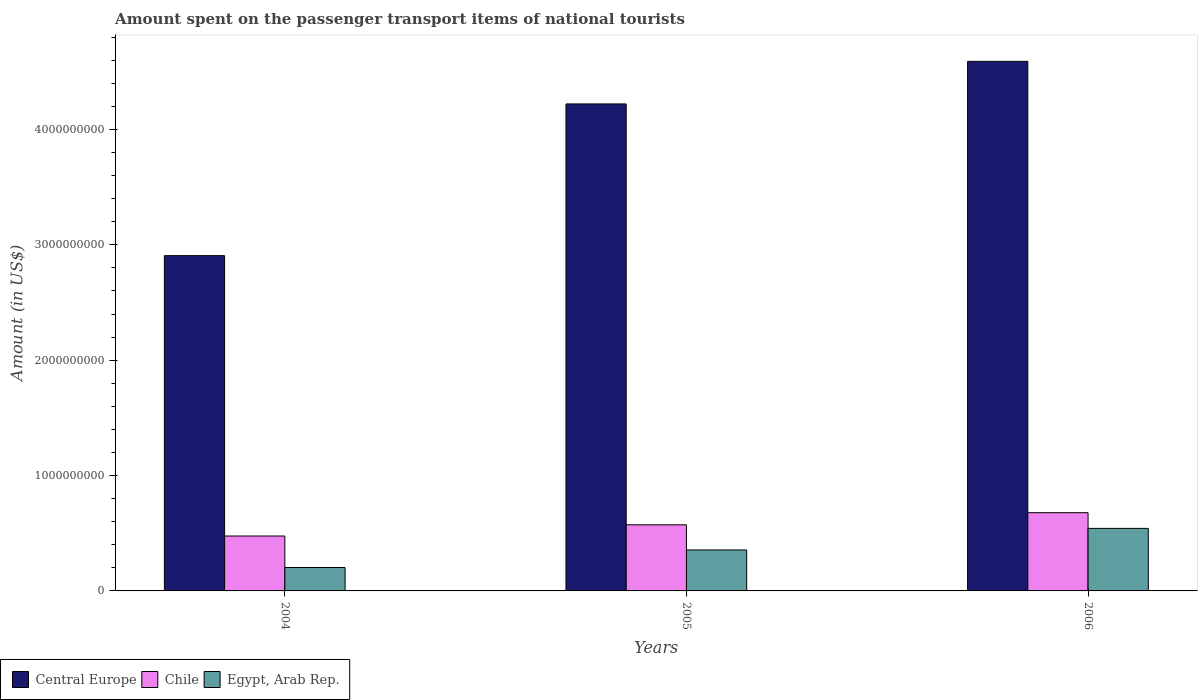How many different coloured bars are there?
Provide a succinct answer. 3. Are the number of bars per tick equal to the number of legend labels?
Keep it short and to the point. Yes. Are the number of bars on each tick of the X-axis equal?
Your response must be concise. Yes. How many bars are there on the 3rd tick from the left?
Provide a succinct answer. 3. How many bars are there on the 1st tick from the right?
Your answer should be compact. 3. What is the label of the 2nd group of bars from the left?
Offer a terse response. 2005. What is the amount spent on the passenger transport items of national tourists in Chile in 2006?
Give a very brief answer. 6.78e+08. Across all years, what is the maximum amount spent on the passenger transport items of national tourists in Egypt, Arab Rep.?
Your answer should be compact. 5.42e+08. Across all years, what is the minimum amount spent on the passenger transport items of national tourists in Chile?
Make the answer very short. 4.76e+08. In which year was the amount spent on the passenger transport items of national tourists in Chile minimum?
Make the answer very short. 2004. What is the total amount spent on the passenger transport items of national tourists in Egypt, Arab Rep. in the graph?
Give a very brief answer. 1.10e+09. What is the difference between the amount spent on the passenger transport items of national tourists in Central Europe in 2004 and that in 2006?
Provide a succinct answer. -1.68e+09. What is the difference between the amount spent on the passenger transport items of national tourists in Egypt, Arab Rep. in 2005 and the amount spent on the passenger transport items of national tourists in Central Europe in 2006?
Give a very brief answer. -4.24e+09. What is the average amount spent on the passenger transport items of national tourists in Chile per year?
Provide a succinct answer. 5.76e+08. In the year 2005, what is the difference between the amount spent on the passenger transport items of national tourists in Central Europe and amount spent on the passenger transport items of national tourists in Egypt, Arab Rep.?
Make the answer very short. 3.87e+09. What is the ratio of the amount spent on the passenger transport items of national tourists in Egypt, Arab Rep. in 2005 to that in 2006?
Ensure brevity in your answer.  0.65. What is the difference between the highest and the second highest amount spent on the passenger transport items of national tourists in Chile?
Offer a terse response. 1.05e+08. What is the difference between the highest and the lowest amount spent on the passenger transport items of national tourists in Egypt, Arab Rep.?
Make the answer very short. 3.39e+08. In how many years, is the amount spent on the passenger transport items of national tourists in Egypt, Arab Rep. greater than the average amount spent on the passenger transport items of national tourists in Egypt, Arab Rep. taken over all years?
Provide a succinct answer. 1. What does the 1st bar from the left in 2005 represents?
Your response must be concise. Central Europe. What does the 1st bar from the right in 2006 represents?
Give a very brief answer. Egypt, Arab Rep. Is it the case that in every year, the sum of the amount spent on the passenger transport items of national tourists in Chile and amount spent on the passenger transport items of national tourists in Egypt, Arab Rep. is greater than the amount spent on the passenger transport items of national tourists in Central Europe?
Give a very brief answer. No. Are all the bars in the graph horizontal?
Make the answer very short. No. How many years are there in the graph?
Offer a terse response. 3. Are the values on the major ticks of Y-axis written in scientific E-notation?
Ensure brevity in your answer.  No. Does the graph contain grids?
Make the answer very short. No. Where does the legend appear in the graph?
Provide a succinct answer. Bottom left. How many legend labels are there?
Make the answer very short. 3. What is the title of the graph?
Your answer should be compact. Amount spent on the passenger transport items of national tourists. Does "Middle East & North Africa (developing only)" appear as one of the legend labels in the graph?
Your response must be concise. No. What is the label or title of the Y-axis?
Make the answer very short. Amount (in US$). What is the Amount (in US$) of Central Europe in 2004?
Make the answer very short. 2.91e+09. What is the Amount (in US$) of Chile in 2004?
Your answer should be compact. 4.76e+08. What is the Amount (in US$) of Egypt, Arab Rep. in 2004?
Your answer should be compact. 2.03e+08. What is the Amount (in US$) in Central Europe in 2005?
Keep it short and to the point. 4.22e+09. What is the Amount (in US$) of Chile in 2005?
Your response must be concise. 5.73e+08. What is the Amount (in US$) in Egypt, Arab Rep. in 2005?
Provide a short and direct response. 3.55e+08. What is the Amount (in US$) in Central Europe in 2006?
Make the answer very short. 4.59e+09. What is the Amount (in US$) in Chile in 2006?
Ensure brevity in your answer.  6.78e+08. What is the Amount (in US$) of Egypt, Arab Rep. in 2006?
Ensure brevity in your answer.  5.42e+08. Across all years, what is the maximum Amount (in US$) of Central Europe?
Your response must be concise. 4.59e+09. Across all years, what is the maximum Amount (in US$) of Chile?
Ensure brevity in your answer.  6.78e+08. Across all years, what is the maximum Amount (in US$) of Egypt, Arab Rep.?
Offer a terse response. 5.42e+08. Across all years, what is the minimum Amount (in US$) in Central Europe?
Offer a terse response. 2.91e+09. Across all years, what is the minimum Amount (in US$) of Chile?
Keep it short and to the point. 4.76e+08. Across all years, what is the minimum Amount (in US$) in Egypt, Arab Rep.?
Make the answer very short. 2.03e+08. What is the total Amount (in US$) of Central Europe in the graph?
Ensure brevity in your answer.  1.17e+1. What is the total Amount (in US$) of Chile in the graph?
Your response must be concise. 1.73e+09. What is the total Amount (in US$) in Egypt, Arab Rep. in the graph?
Your answer should be very brief. 1.10e+09. What is the difference between the Amount (in US$) of Central Europe in 2004 and that in 2005?
Your answer should be very brief. -1.32e+09. What is the difference between the Amount (in US$) in Chile in 2004 and that in 2005?
Your answer should be compact. -9.70e+07. What is the difference between the Amount (in US$) of Egypt, Arab Rep. in 2004 and that in 2005?
Provide a succinct answer. -1.52e+08. What is the difference between the Amount (in US$) of Central Europe in 2004 and that in 2006?
Make the answer very short. -1.68e+09. What is the difference between the Amount (in US$) in Chile in 2004 and that in 2006?
Your response must be concise. -2.02e+08. What is the difference between the Amount (in US$) in Egypt, Arab Rep. in 2004 and that in 2006?
Your answer should be very brief. -3.39e+08. What is the difference between the Amount (in US$) of Central Europe in 2005 and that in 2006?
Offer a terse response. -3.69e+08. What is the difference between the Amount (in US$) of Chile in 2005 and that in 2006?
Provide a succinct answer. -1.05e+08. What is the difference between the Amount (in US$) in Egypt, Arab Rep. in 2005 and that in 2006?
Offer a very short reply. -1.87e+08. What is the difference between the Amount (in US$) of Central Europe in 2004 and the Amount (in US$) of Chile in 2005?
Provide a succinct answer. 2.33e+09. What is the difference between the Amount (in US$) of Central Europe in 2004 and the Amount (in US$) of Egypt, Arab Rep. in 2005?
Make the answer very short. 2.55e+09. What is the difference between the Amount (in US$) of Chile in 2004 and the Amount (in US$) of Egypt, Arab Rep. in 2005?
Your answer should be very brief. 1.21e+08. What is the difference between the Amount (in US$) in Central Europe in 2004 and the Amount (in US$) in Chile in 2006?
Provide a succinct answer. 2.23e+09. What is the difference between the Amount (in US$) in Central Europe in 2004 and the Amount (in US$) in Egypt, Arab Rep. in 2006?
Make the answer very short. 2.36e+09. What is the difference between the Amount (in US$) of Chile in 2004 and the Amount (in US$) of Egypt, Arab Rep. in 2006?
Make the answer very short. -6.60e+07. What is the difference between the Amount (in US$) of Central Europe in 2005 and the Amount (in US$) of Chile in 2006?
Make the answer very short. 3.54e+09. What is the difference between the Amount (in US$) of Central Europe in 2005 and the Amount (in US$) of Egypt, Arab Rep. in 2006?
Your answer should be very brief. 3.68e+09. What is the difference between the Amount (in US$) of Chile in 2005 and the Amount (in US$) of Egypt, Arab Rep. in 2006?
Offer a terse response. 3.10e+07. What is the average Amount (in US$) of Central Europe per year?
Your answer should be very brief. 3.91e+09. What is the average Amount (in US$) in Chile per year?
Your response must be concise. 5.76e+08. What is the average Amount (in US$) in Egypt, Arab Rep. per year?
Your answer should be very brief. 3.67e+08. In the year 2004, what is the difference between the Amount (in US$) in Central Europe and Amount (in US$) in Chile?
Your answer should be compact. 2.43e+09. In the year 2004, what is the difference between the Amount (in US$) of Central Europe and Amount (in US$) of Egypt, Arab Rep.?
Your answer should be compact. 2.70e+09. In the year 2004, what is the difference between the Amount (in US$) in Chile and Amount (in US$) in Egypt, Arab Rep.?
Keep it short and to the point. 2.73e+08. In the year 2005, what is the difference between the Amount (in US$) in Central Europe and Amount (in US$) in Chile?
Offer a very short reply. 3.65e+09. In the year 2005, what is the difference between the Amount (in US$) in Central Europe and Amount (in US$) in Egypt, Arab Rep.?
Your answer should be compact. 3.87e+09. In the year 2005, what is the difference between the Amount (in US$) in Chile and Amount (in US$) in Egypt, Arab Rep.?
Provide a short and direct response. 2.18e+08. In the year 2006, what is the difference between the Amount (in US$) of Central Europe and Amount (in US$) of Chile?
Offer a terse response. 3.91e+09. In the year 2006, what is the difference between the Amount (in US$) in Central Europe and Amount (in US$) in Egypt, Arab Rep.?
Keep it short and to the point. 4.05e+09. In the year 2006, what is the difference between the Amount (in US$) in Chile and Amount (in US$) in Egypt, Arab Rep.?
Make the answer very short. 1.36e+08. What is the ratio of the Amount (in US$) in Central Europe in 2004 to that in 2005?
Your response must be concise. 0.69. What is the ratio of the Amount (in US$) of Chile in 2004 to that in 2005?
Keep it short and to the point. 0.83. What is the ratio of the Amount (in US$) in Egypt, Arab Rep. in 2004 to that in 2005?
Provide a succinct answer. 0.57. What is the ratio of the Amount (in US$) in Central Europe in 2004 to that in 2006?
Ensure brevity in your answer.  0.63. What is the ratio of the Amount (in US$) in Chile in 2004 to that in 2006?
Offer a very short reply. 0.7. What is the ratio of the Amount (in US$) in Egypt, Arab Rep. in 2004 to that in 2006?
Your answer should be compact. 0.37. What is the ratio of the Amount (in US$) in Central Europe in 2005 to that in 2006?
Make the answer very short. 0.92. What is the ratio of the Amount (in US$) of Chile in 2005 to that in 2006?
Your response must be concise. 0.85. What is the ratio of the Amount (in US$) of Egypt, Arab Rep. in 2005 to that in 2006?
Keep it short and to the point. 0.66. What is the difference between the highest and the second highest Amount (in US$) of Central Europe?
Your answer should be compact. 3.69e+08. What is the difference between the highest and the second highest Amount (in US$) of Chile?
Your answer should be very brief. 1.05e+08. What is the difference between the highest and the second highest Amount (in US$) in Egypt, Arab Rep.?
Keep it short and to the point. 1.87e+08. What is the difference between the highest and the lowest Amount (in US$) of Central Europe?
Make the answer very short. 1.68e+09. What is the difference between the highest and the lowest Amount (in US$) of Chile?
Your answer should be compact. 2.02e+08. What is the difference between the highest and the lowest Amount (in US$) of Egypt, Arab Rep.?
Your answer should be very brief. 3.39e+08. 